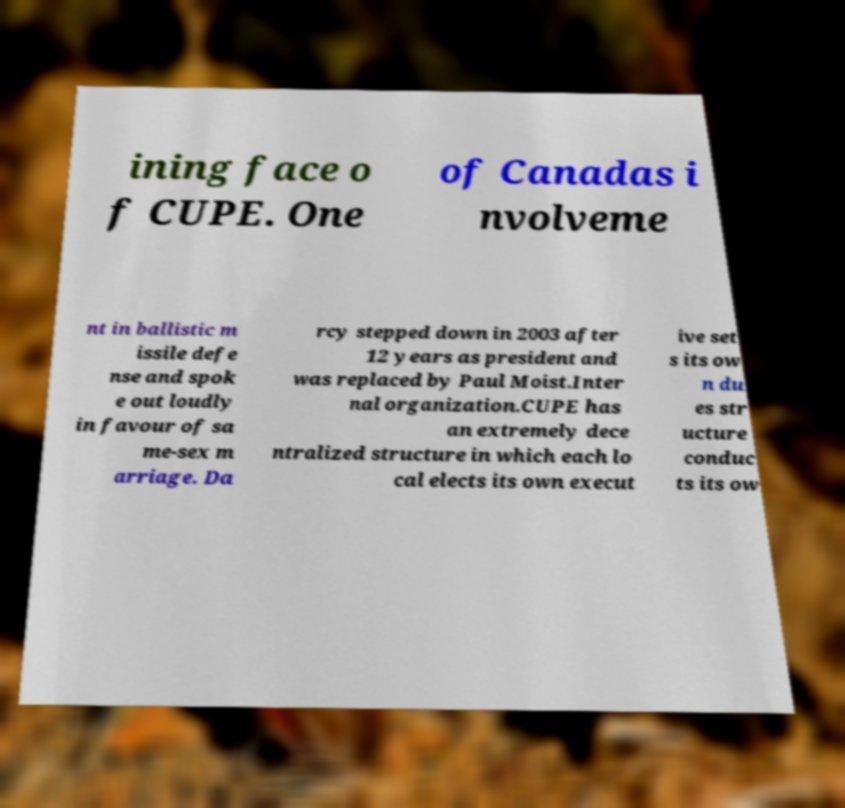Please read and relay the text visible in this image. What does it say? ining face o f CUPE. One of Canadas i nvolveme nt in ballistic m issile defe nse and spok e out loudly in favour of sa me-sex m arriage. Da rcy stepped down in 2003 after 12 years as president and was replaced by Paul Moist.Inter nal organization.CUPE has an extremely dece ntralized structure in which each lo cal elects its own execut ive set s its ow n du es str ucture conduc ts its ow 